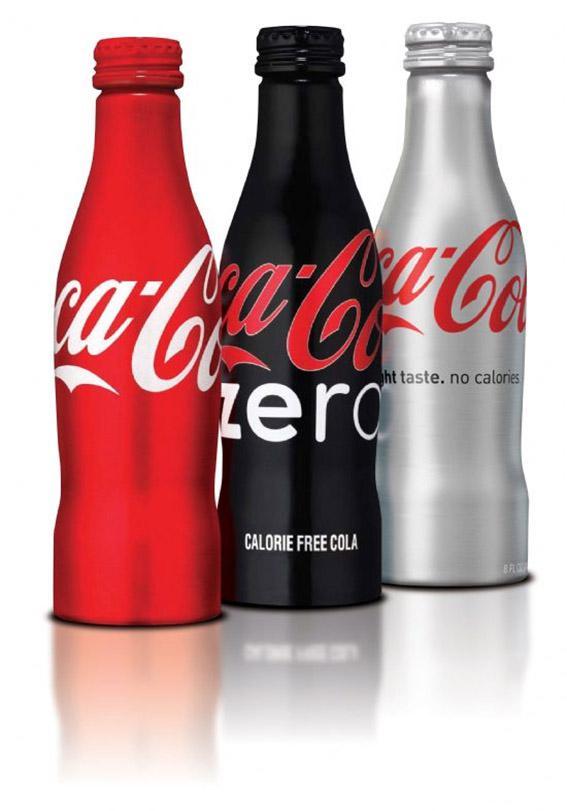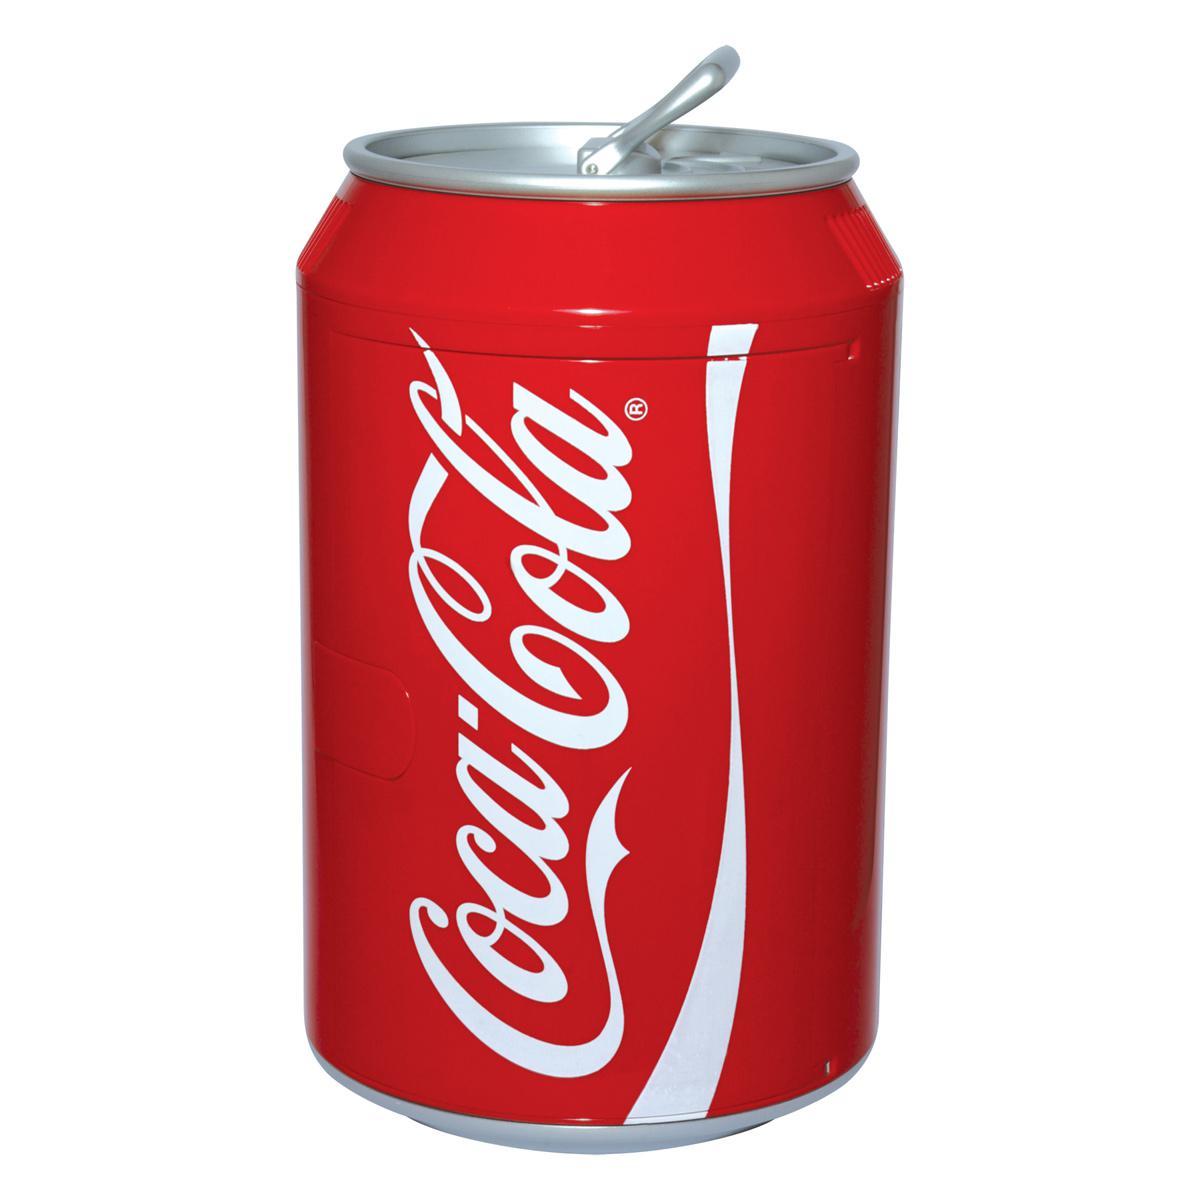The first image is the image on the left, the second image is the image on the right. Evaluate the accuracy of this statement regarding the images: "Each image includes at least one bottle that is bright red with writing in white script letters around its middle.". Is it true? Answer yes or no. No. The first image is the image on the left, the second image is the image on the right. Considering the images on both sides, is "Some of the beverages are sugar free." valid? Answer yes or no. Yes. 